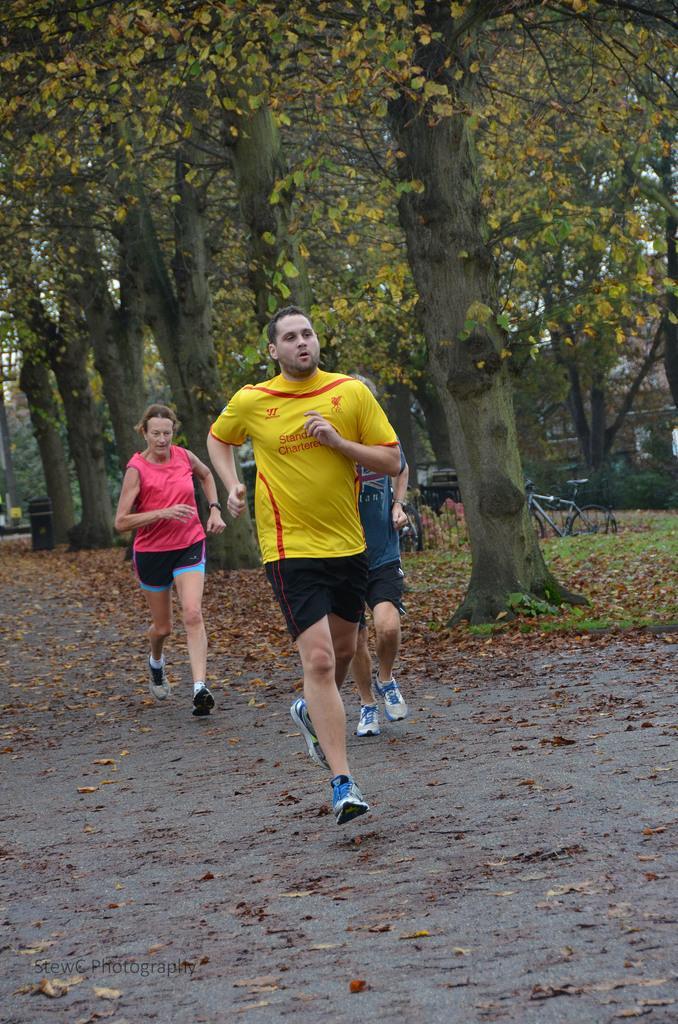Describe this image in one or two sentences. As we can see in the image there are three people running on road. Behind the person's there are group of trees. In the background there is a bicycle. 